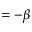Convert formula to latex. <formula><loc_0><loc_0><loc_500><loc_500>= - \beta</formula> 